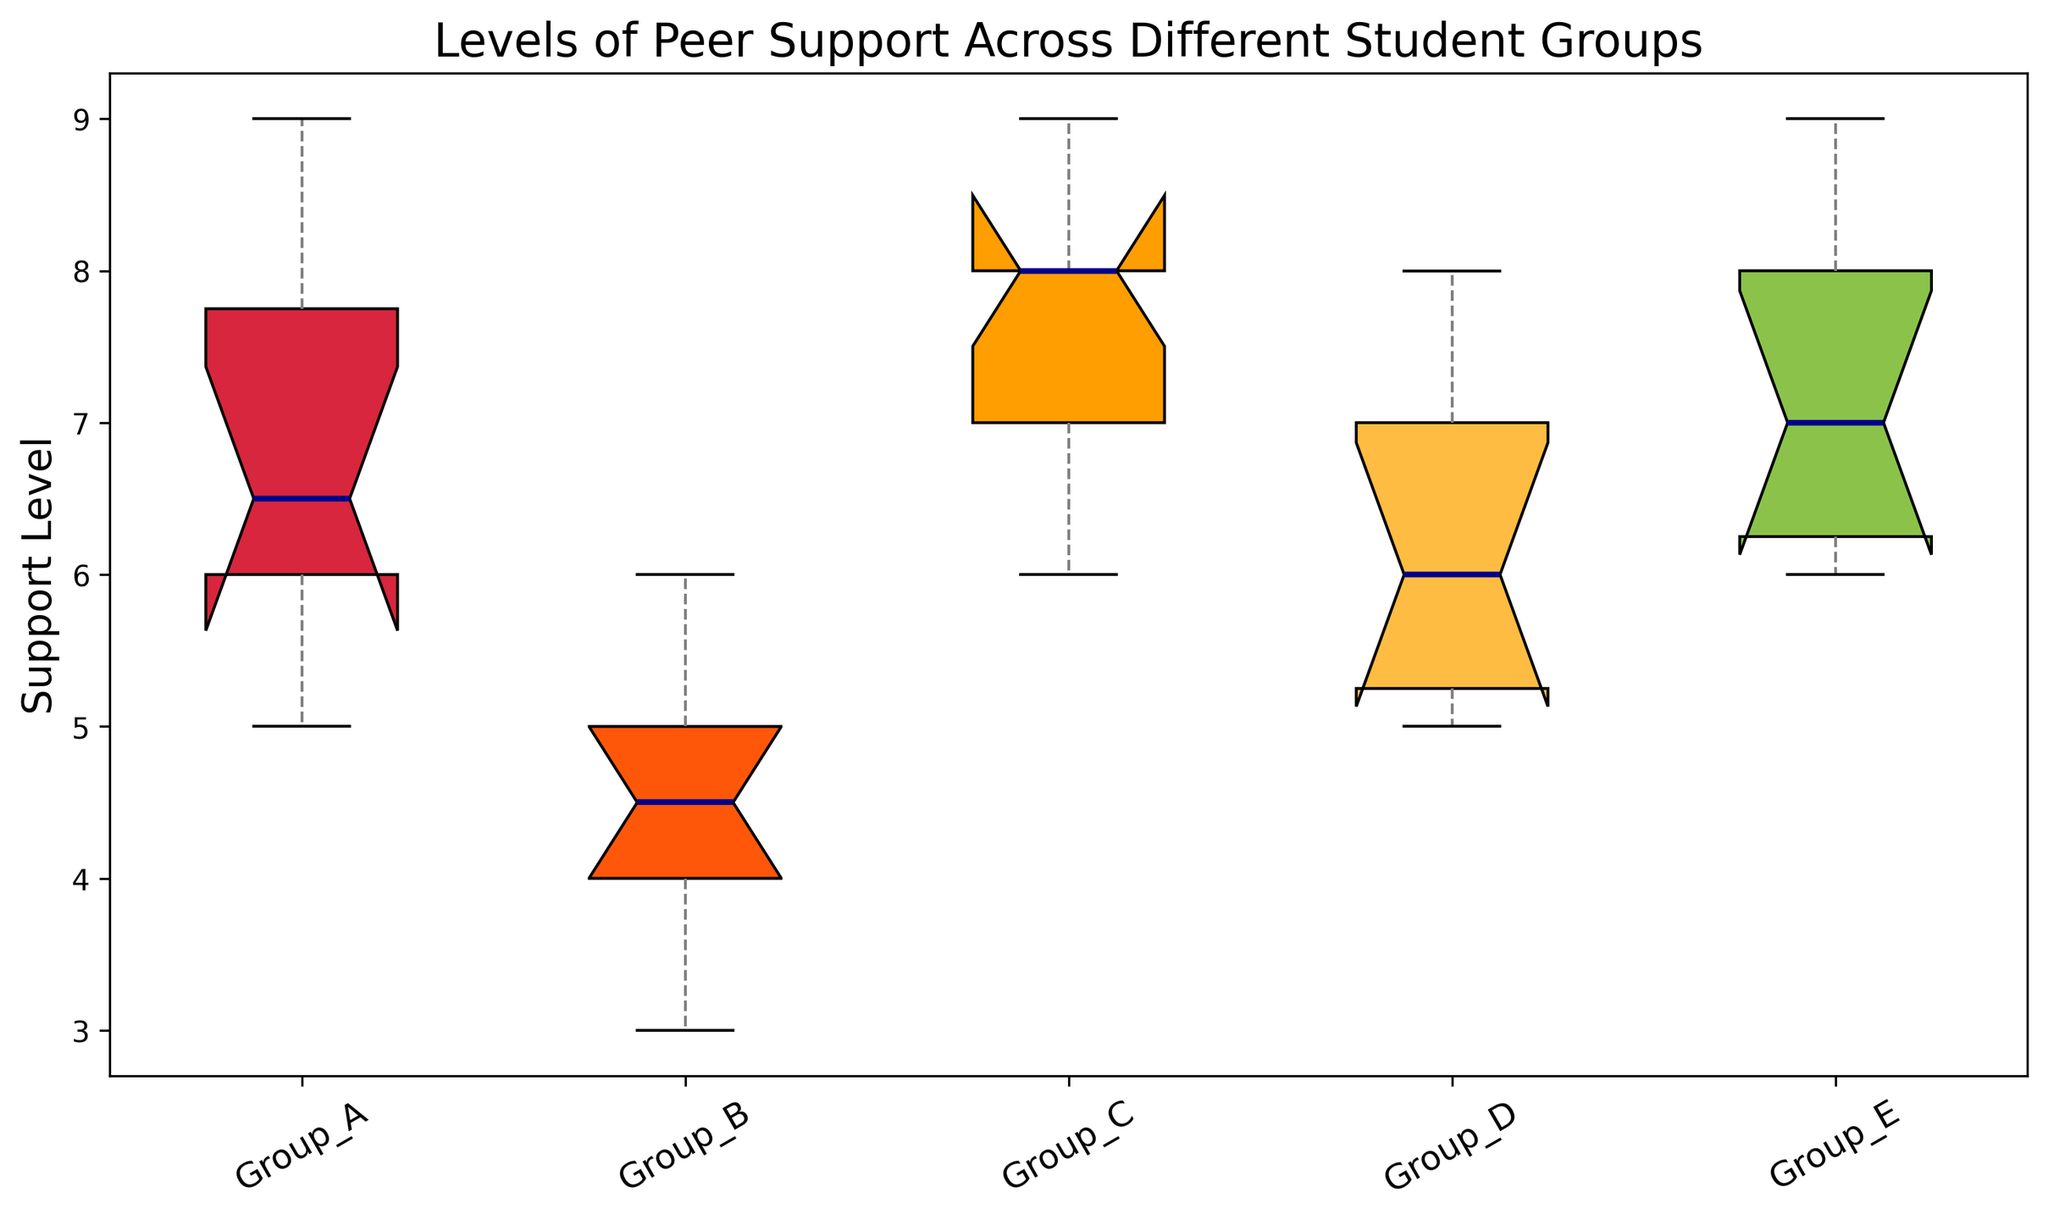What's the highest value observed in Group C? The box plot for Group C shows the range of values as indicated by the whiskers. The top whisker, which represents the maximum value, touches the highest data point observed for Group C. Looking at the plot, the highest value observed in Group C is 9.
Answer: 9 Which group has the highest median support level? The median is represented by the line inside the box of each group. Comparing the medians of all groups, Group C has the highest median, as its line is positioned higher on the y-axis compared to the others.
Answer: Group C Is the interquartile range (IQR) of Group B greater than that of Group D? The IQR is the length of the box, which represents the range between the first quartile (lower edge of the box) and the third quartile (upper edge of the box). To determine if Group B's IQR is greater than Group D's, examine and compare their box lengths. Group B's box (IQR) appears larger than Group D's.
Answer: Yes How does the spread (range) of values in Group A compare to Group E? The spread or range is indicated by the distance between the bottom and top whiskers. For Group A, the range goes from 5 to 9. For Group E, the range also goes from 6 to 9. Although Group A has a slightly larger range, both groups' maximum values are the same.
Answer: Group A has a slightly larger range Which group has the smallest range of support levels? The range is shown by the distance between the lowest and highest whiskers. Comparing the lengths of all whiskers, Group D has the smallest range of support levels.
Answer: Group D How do the whiskers of Group B compare to those of Group C in terms of indicating variability? Whiskers give a sense of variability in the data. Comparing the length of the whiskers, Group B shows longer whiskers, indicating more variability in support levels compared to Group C, which has shorter whiskers.
Answer: Group B has more variability Is the median support level in Group A higher than the mean support level in Group B? The median support level is the middle line in Group A's box, which is at 7. Calculating the mean support level for Group B as (4+5+3+4+6+4+5+6+3+5)/10 = 4.5, we find that the median of Group A (7) is higher than the mean of Group B (4.5).
Answer: Yes Compare the lower quartile (25th percentile) of Group C and Group D. Which is higher? The lower quartile is the bottom edge of the box. Comparing Group C and Group D, the lower quartile for Group C (7) is higher than that for Group D (5.5).
Answer: Group C Which group has the most symmetrical distribution of support levels? A symmetrical distribution would imply that the median is in the center of the box and the whiskers are of relatively equal length. Based on the box plot, Group D appears to have the most symmetrical distribution given its box and whiskers are well-balanced around the median.
Answer: Group D 